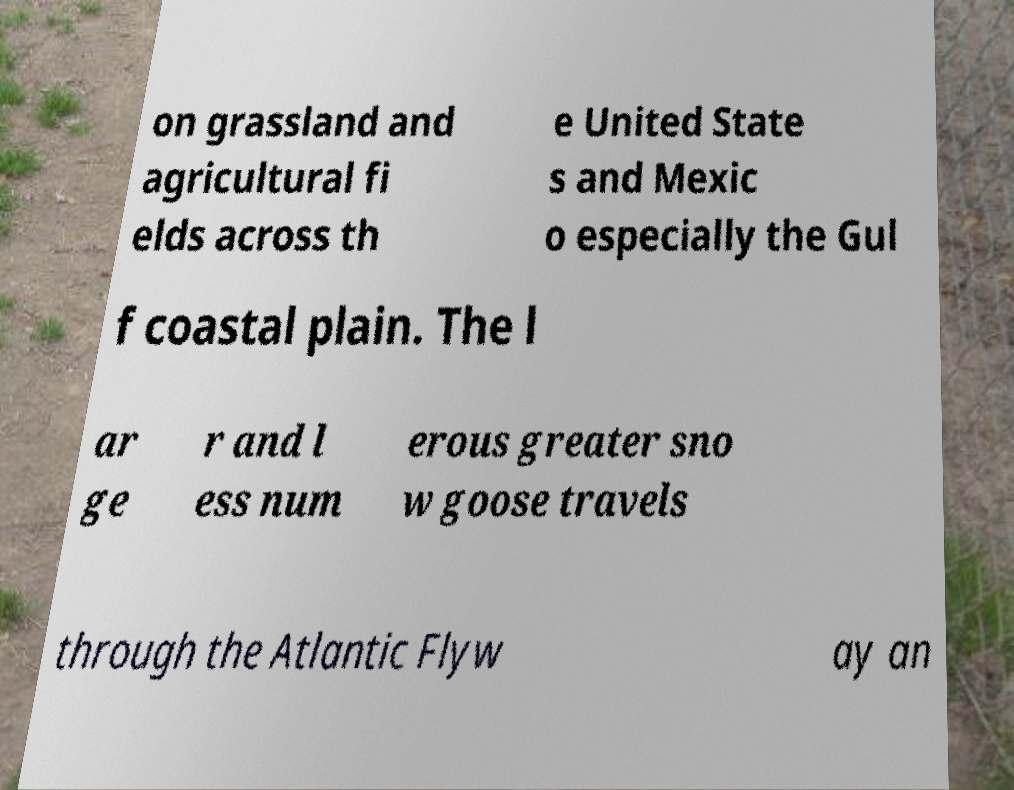Could you assist in decoding the text presented in this image and type it out clearly? on grassland and agricultural fi elds across th e United State s and Mexic o especially the Gul f coastal plain. The l ar ge r and l ess num erous greater sno w goose travels through the Atlantic Flyw ay an 